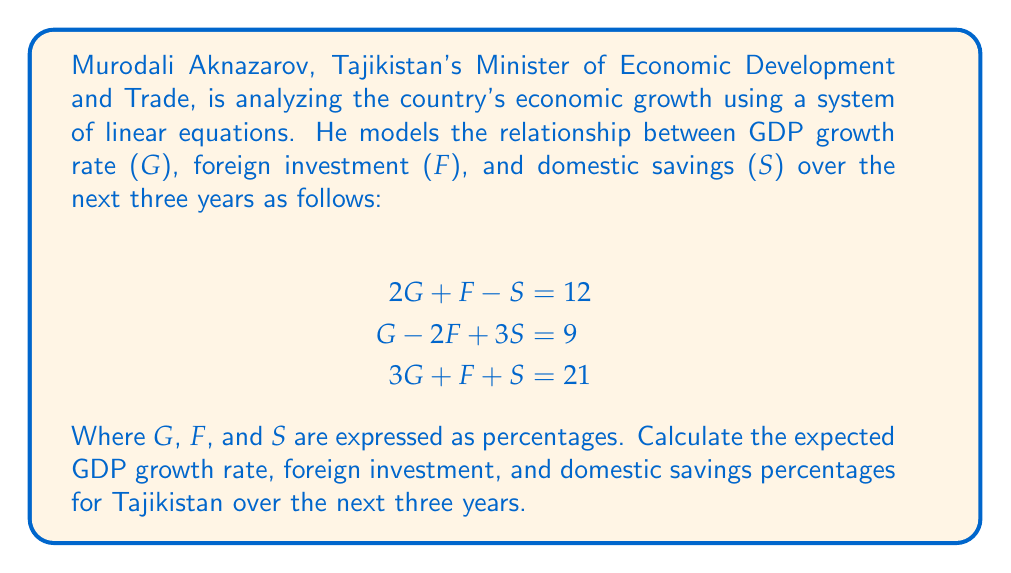What is the answer to this math problem? To solve this system of linear equations, we'll use the Gaussian elimination method:

1) First, let's write the augmented matrix:

$$\begin{bmatrix}
2 & 1 & -1 & 12 \\
1 & -2 & 3 & 9 \\
3 & 1 & 1 & 21
\end{bmatrix}$$

2) Multiply the first row by -1/2 and add it to the second row:

$$\begin{bmatrix}
2 & 1 & -1 & 12 \\
0 & -2.5 & 3.5 & 3 \\
3 & 1 & 1 & 21
\end{bmatrix}$$

3) Multiply the first row by -3/2 and add it to the third row:

$$\begin{bmatrix}
2 & 1 & -1 & 12 \\
0 & -2.5 & 3.5 & 3 \\
0 & -0.5 & 2.5 & 3
\end{bmatrix}$$

4) Multiply the second row by 1/5 and add it to the third row:

$$\begin{bmatrix}
2 & 1 & -1 & 12 \\
0 & -2.5 & 3.5 & 3 \\
0 & 0 & 1.8 & 3.6
\end{bmatrix}$$

5) Now we have an upper triangular matrix. Let's solve for S:

$1.8S = 3.6$
$S = 2$

6) Substitute S = 2 into the second equation:

$-2.5F + 3.5(2) = 3$
$-2.5F + 7 = 3$
$-2.5F = -4$
$F = 1.6$

7) Finally, substitute S = 2 and F = 1.6 into the first equation:

$2G + 1.6 - 2 = 12$
$2G = 12.4$
$G = 6.2$

Therefore, G = 6.2%, F = 1.6%, and S = 2%.
Answer: GDP growth rate (G) = 6.2%
Foreign investment (F) = 1.6%
Domestic savings (S) = 2% 